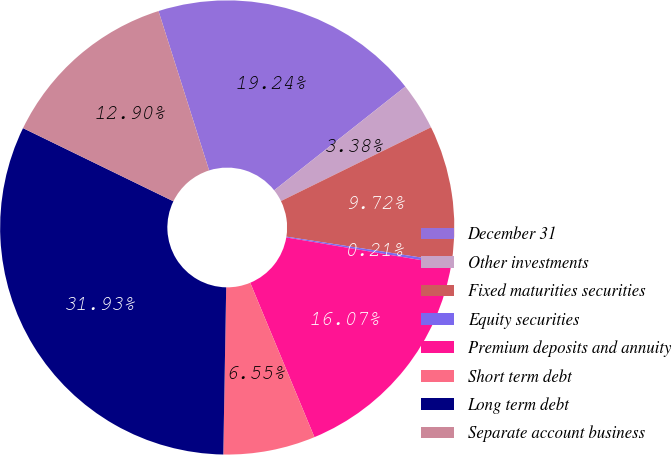Convert chart to OTSL. <chart><loc_0><loc_0><loc_500><loc_500><pie_chart><fcel>December 31<fcel>Other investments<fcel>Fixed maturities securities<fcel>Equity securities<fcel>Premium deposits and annuity<fcel>Short term debt<fcel>Long term debt<fcel>Separate account business<nl><fcel>19.24%<fcel>3.38%<fcel>9.72%<fcel>0.21%<fcel>16.07%<fcel>6.55%<fcel>31.93%<fcel>12.9%<nl></chart> 